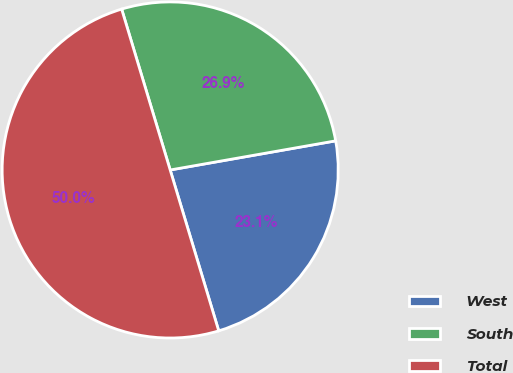<chart> <loc_0><loc_0><loc_500><loc_500><pie_chart><fcel>West<fcel>South<fcel>Total<nl><fcel>23.11%<fcel>26.89%<fcel>50.0%<nl></chart> 